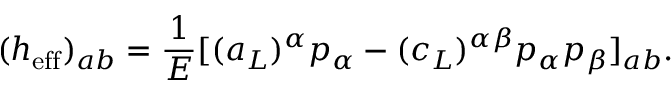<formula> <loc_0><loc_0><loc_500><loc_500>( h _ { e f f } ) _ { a b } = { \frac { 1 } { E } } [ ( a _ { L } ) ^ { \alpha } p _ { \alpha } - ( c _ { L } ) ^ { \alpha \beta } p _ { \alpha } p _ { \beta } ] _ { a b } .</formula> 